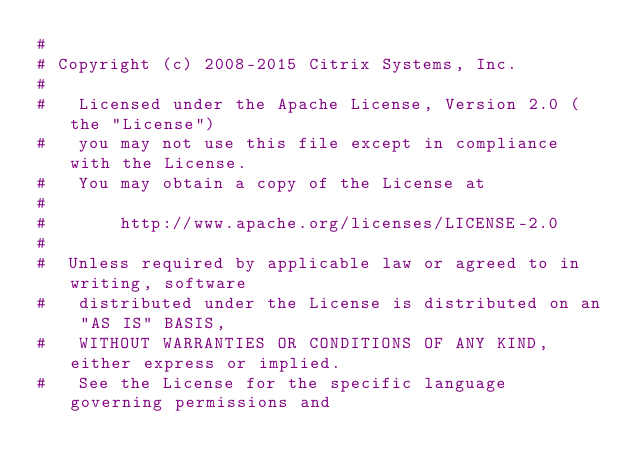Convert code to text. <code><loc_0><loc_0><loc_500><loc_500><_Python_>#
# Copyright (c) 2008-2015 Citrix Systems, Inc.
#
#   Licensed under the Apache License, Version 2.0 (the "License")
#   you may not use this file except in compliance with the License.
#   You may obtain a copy of the License at
#
#       http://www.apache.org/licenses/LICENSE-2.0
#
#  Unless required by applicable law or agreed to in writing, software
#   distributed under the License is distributed on an "AS IS" BASIS,
#   WITHOUT WARRANTIES OR CONDITIONS OF ANY KIND, either express or implied.
#   See the License for the specific language governing permissions and</code> 